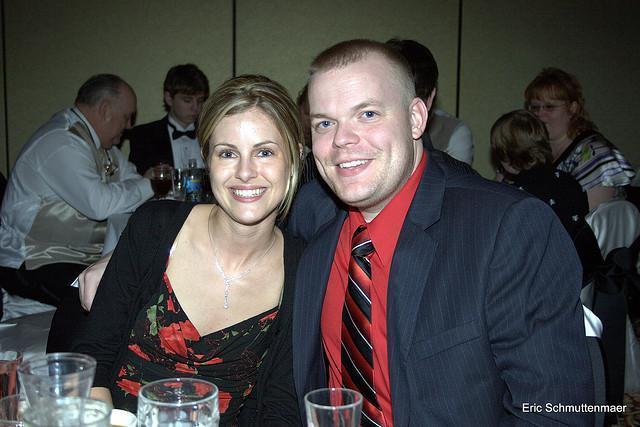Persons here are likely attending what type reception?
Answer the question by selecting the correct answer among the 4 following choices and explain your choice with a short sentence. The answer should be formatted with the following format: `Answer: choice
Rationale: rationale.`
Options: Wedding, retirement, business, funeral. Answer: wedding.
Rationale: The people are dressed up and smiling. 